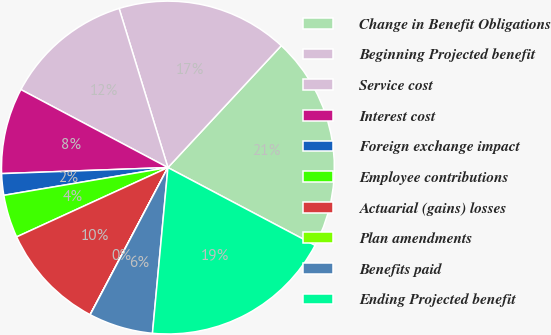Convert chart to OTSL. <chart><loc_0><loc_0><loc_500><loc_500><pie_chart><fcel>Change in Benefit Obligations<fcel>Beginning Projected benefit<fcel>Service cost<fcel>Interest cost<fcel>Foreign exchange impact<fcel>Employee contributions<fcel>Actuarial (gains) losses<fcel>Plan amendments<fcel>Benefits paid<fcel>Ending Projected benefit<nl><fcel>20.82%<fcel>16.66%<fcel>12.5%<fcel>8.34%<fcel>2.09%<fcel>4.17%<fcel>10.42%<fcel>0.01%<fcel>6.25%<fcel>18.74%<nl></chart> 